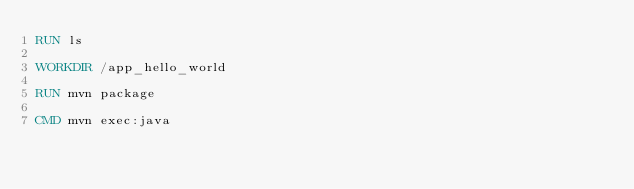<code> <loc_0><loc_0><loc_500><loc_500><_Dockerfile_>RUN ls

WORKDIR /app_hello_world

RUN mvn package

CMD mvn exec:java
</code> 